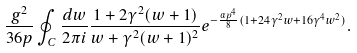<formula> <loc_0><loc_0><loc_500><loc_500>\frac { g ^ { 2 } } { 3 6 p } & \oint _ { C } \frac { d w } { 2 \pi i } \frac { 1 + 2 \gamma ^ { 2 } ( w + 1 ) } { w + \gamma ^ { 2 } ( w + 1 ) ^ { 2 } } e ^ { - \frac { \alpha p ^ { 4 } } { 8 } ( 1 + 2 4 \gamma ^ { 2 } w + 1 6 \gamma ^ { 4 } w ^ { 2 } ) } .</formula> 